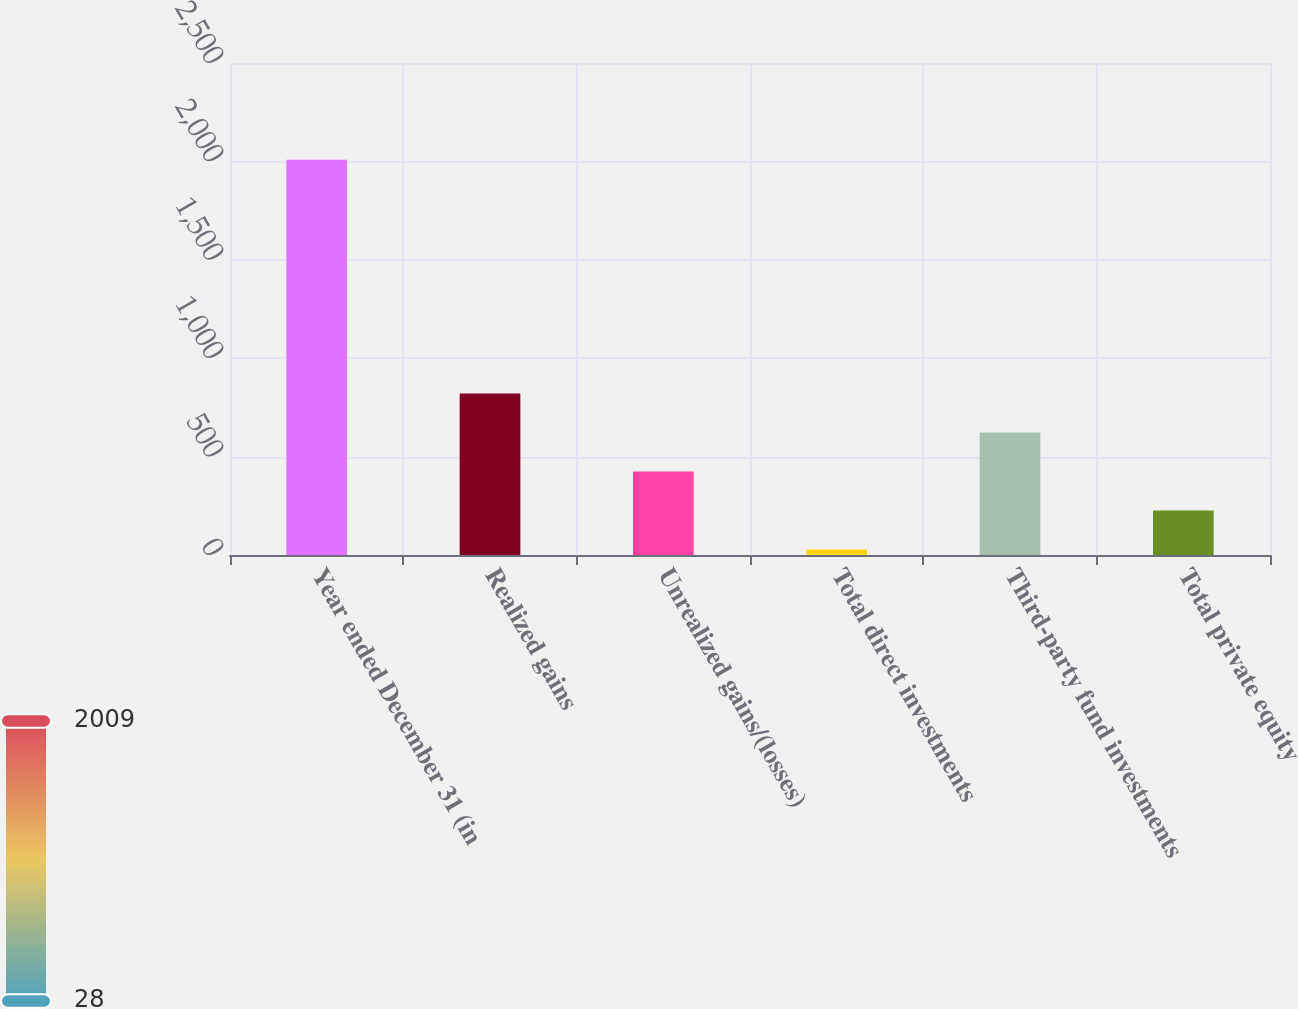Convert chart to OTSL. <chart><loc_0><loc_0><loc_500><loc_500><bar_chart><fcel>Year ended December 31 (in<fcel>Realized gains<fcel>Unrealized gains/(losses)<fcel>Total direct investments<fcel>Third-party fund investments<fcel>Total private equity<nl><fcel>2009<fcel>820.4<fcel>424.2<fcel>28<fcel>622.3<fcel>226.1<nl></chart> 